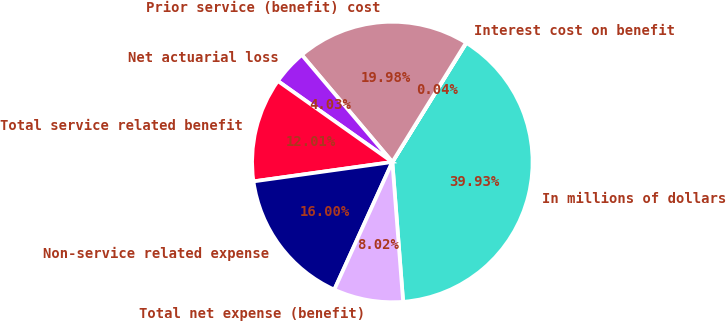Convert chart to OTSL. <chart><loc_0><loc_0><loc_500><loc_500><pie_chart><fcel>In millions of dollars<fcel>Interest cost on benefit<fcel>Prior service (benefit) cost<fcel>Net actuarial loss<fcel>Total service related benefit<fcel>Non-service related expense<fcel>Total net expense (benefit)<nl><fcel>39.93%<fcel>0.04%<fcel>19.98%<fcel>4.03%<fcel>12.01%<fcel>16.0%<fcel>8.02%<nl></chart> 